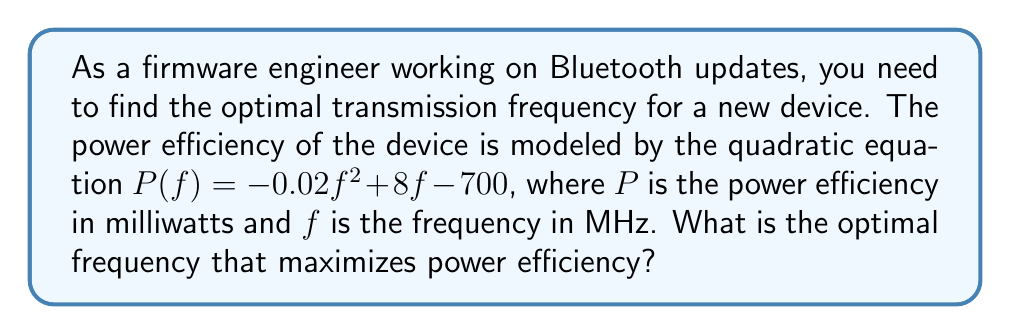Solve this math problem. To find the optimal frequency that maximizes power efficiency, we need to find the vertex of the parabola represented by the quadratic equation. The steps are as follows:

1. Identify the quadratic equation:
   $P(f) = -0.02f^2 + 8f - 700$

2. Compare with the standard form $af^2 + bf + c$:
   $a = -0.02$, $b = 8$, $c = -700$

3. Use the formula for the x-coordinate of the vertex: $f = -\frac{b}{2a}$

4. Substitute the values:
   $f = -\frac{8}{2(-0.02)} = -\frac{8}{-0.04} = \frac{8}{0.04} = 200$

5. Check the second derivative to confirm it's a maximum:
   $\frac{d^2P}{df^2} = -0.04 < 0$, confirming it's a maximum

Therefore, the optimal frequency that maximizes power efficiency is 200 MHz.
Answer: 200 MHz 